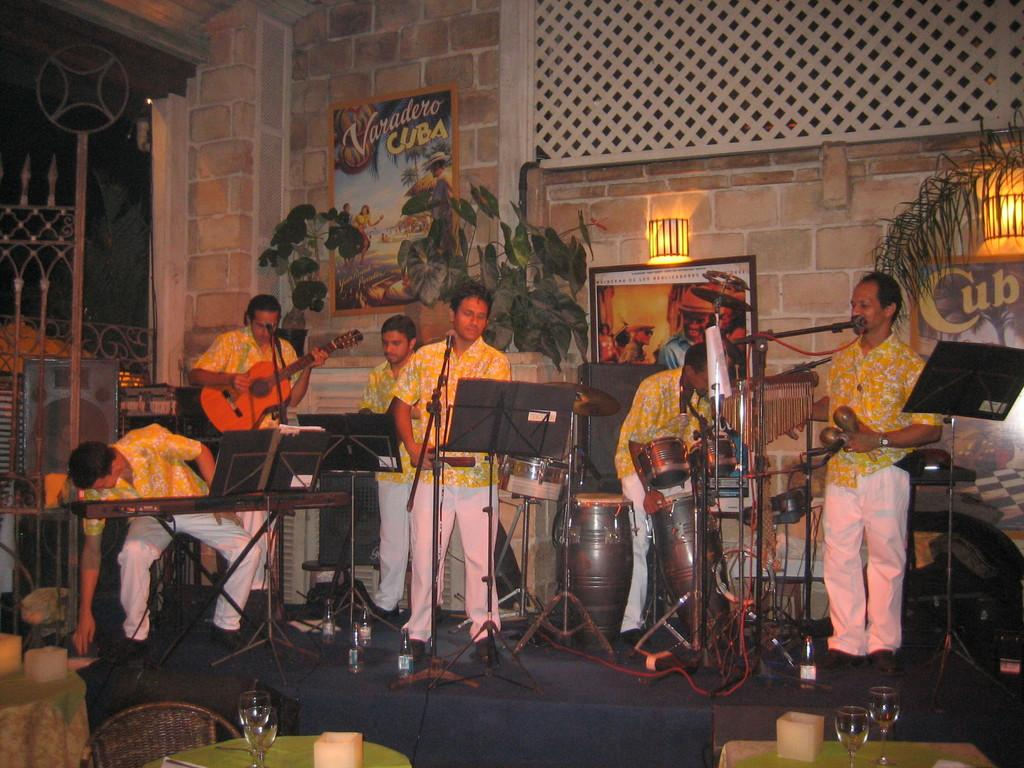What is happening in the image? There is a group of people in the image, and they are playing musical instruments. What can be seen near the group of people? There is a mic in front of the group of people. What type of orange is being sorted in the church in the image? There is no orange or sorting activity present in the image, nor is there a church depicted. 